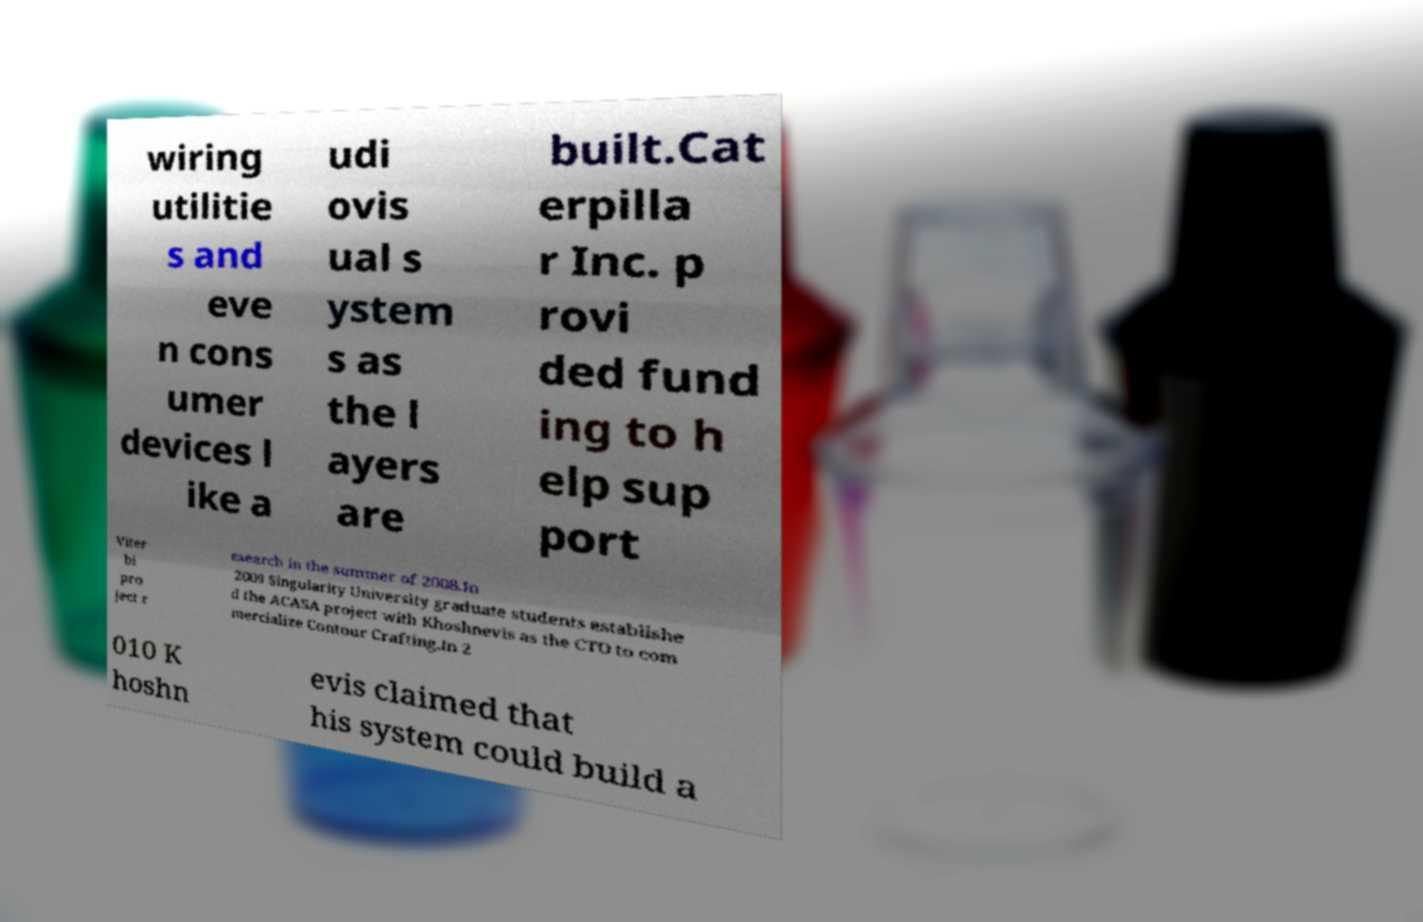Could you extract and type out the text from this image? wiring utilitie s and eve n cons umer devices l ike a udi ovis ual s ystem s as the l ayers are built.Cat erpilla r Inc. p rovi ded fund ing to h elp sup port Viter bi pro ject r esearch in the summer of 2008.In 2009 Singularity University graduate students establishe d the ACASA project with Khoshnevis as the CTO to com mercialize Contour Crafting.In 2 010 K hoshn evis claimed that his system could build a 